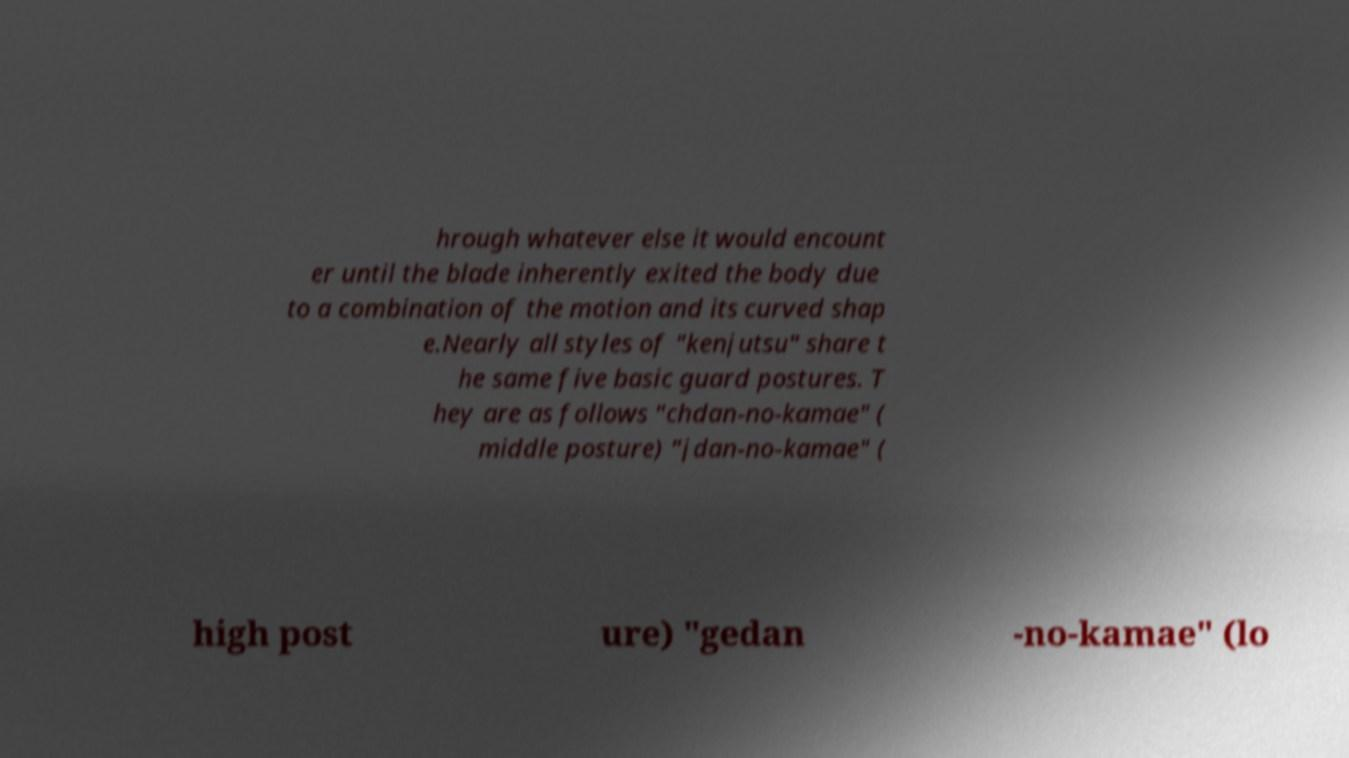Can you read and provide the text displayed in the image?This photo seems to have some interesting text. Can you extract and type it out for me? hrough whatever else it would encount er until the blade inherently exited the body due to a combination of the motion and its curved shap e.Nearly all styles of "kenjutsu" share t he same five basic guard postures. T hey are as follows "chdan-no-kamae" ( middle posture) "jdan-no-kamae" ( high post ure) "gedan -no-kamae" (lo 